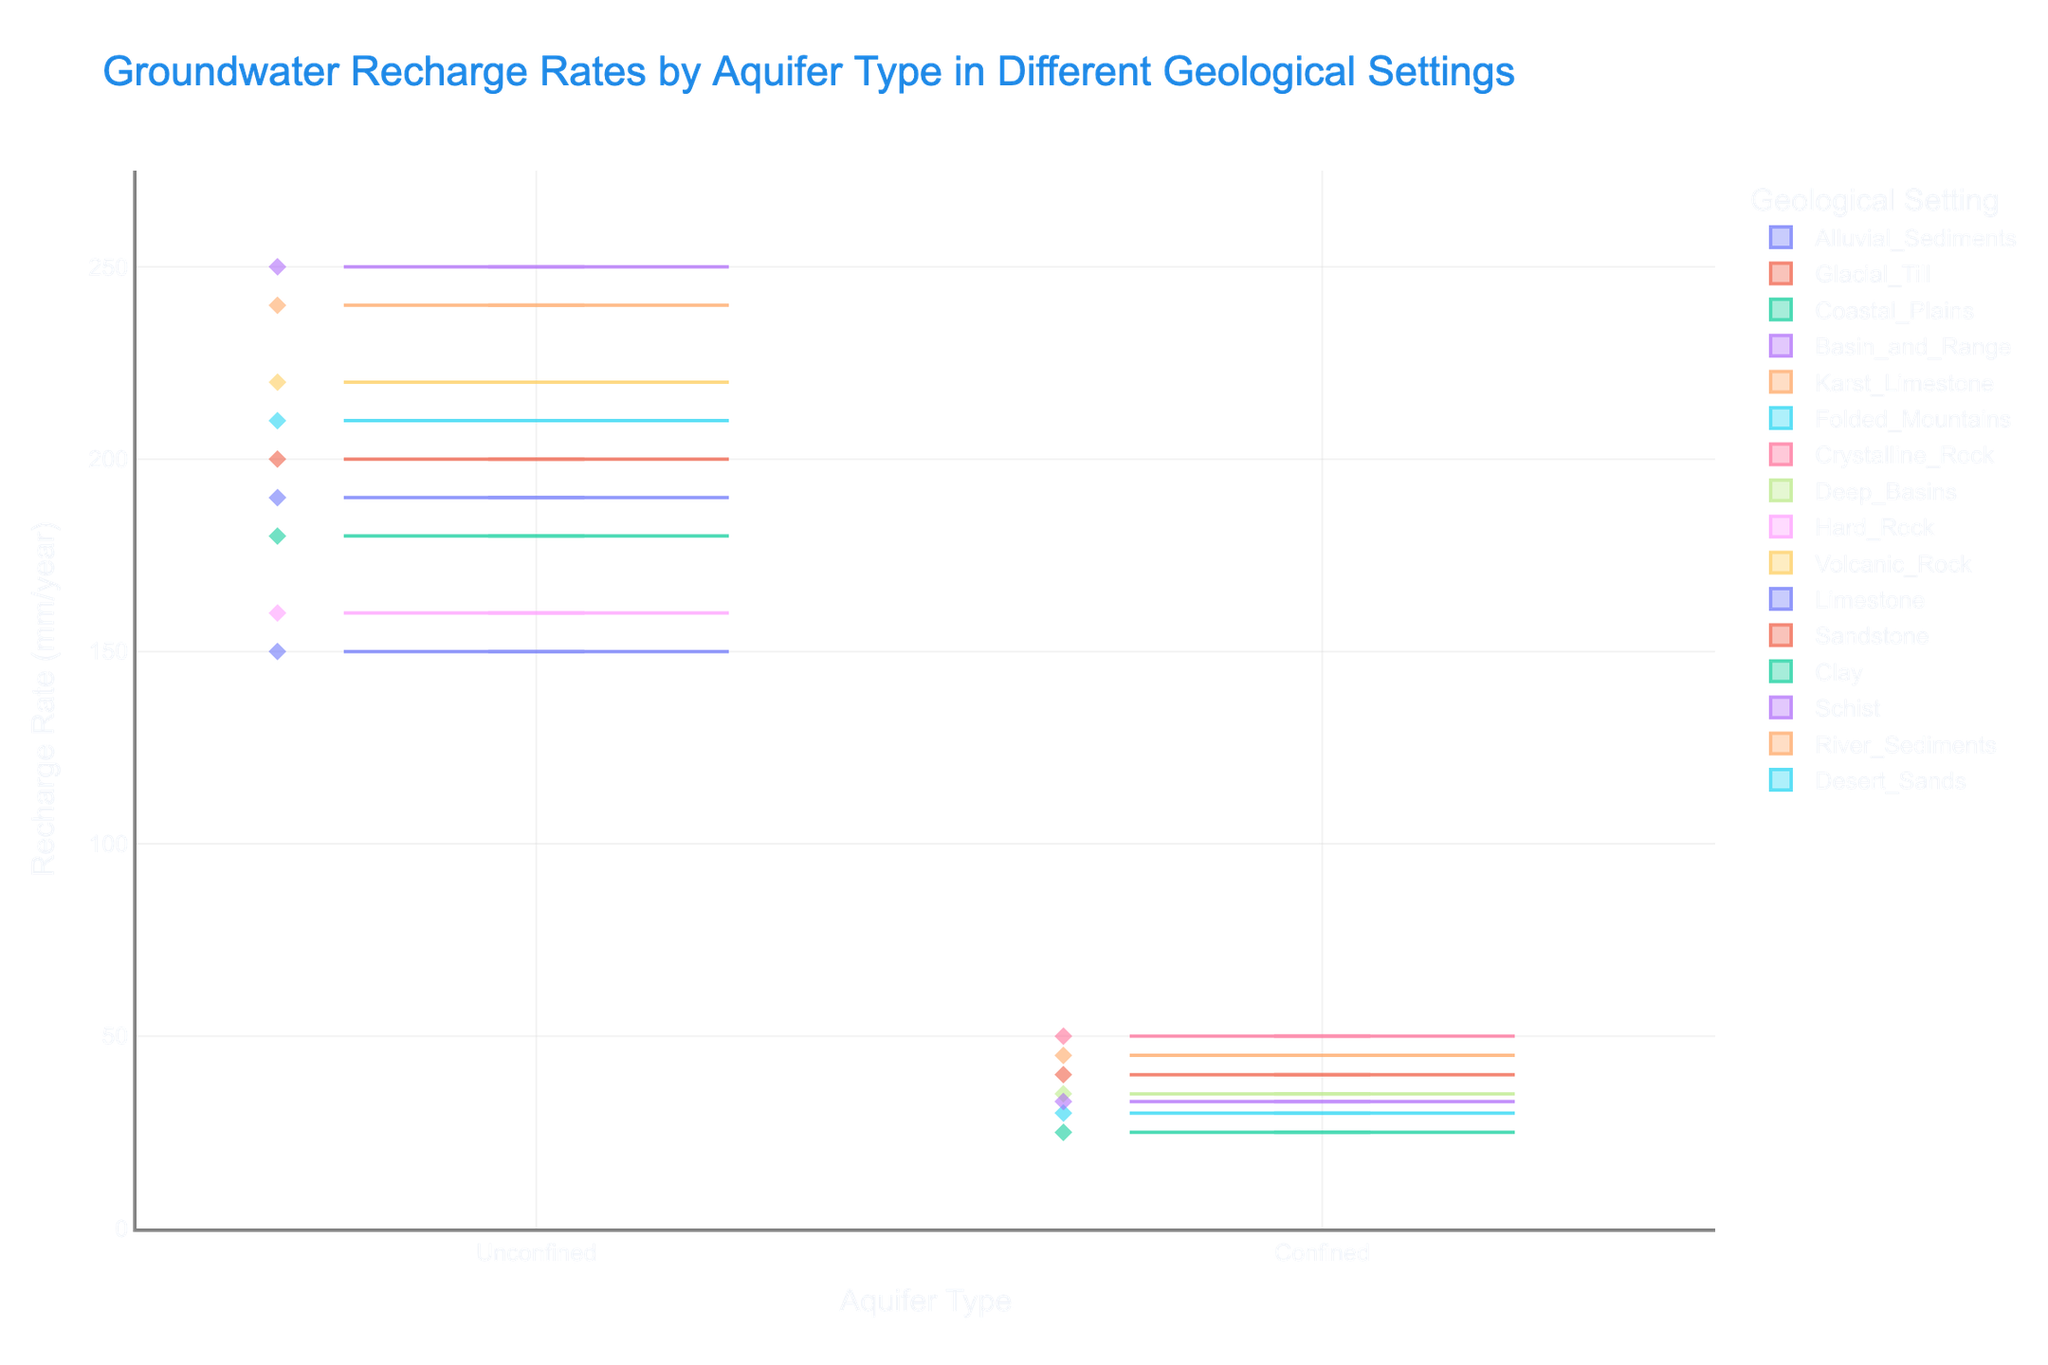What is the title of this violin chart? The title is usually displayed prominently at the top of the chart. In this case, it is clearly stated as "Groundwater Recharge Rates by Aquifer Type in Different Geological Settings".
Answer: Groundwater Recharge Rates by Aquifer Type in Different Geological Settings Which aquifer type has higher recharge rates on average? To determine this, look at the spread and central tendency of the recharge rates for each aquifer type. Unconfined aquifers show data points with higher recharge rates compared to confined aquifers.
Answer: Unconfined What is the range of recharge rates for unconfined aquifers? Examine the violin plot for unconfined aquifers. The range extends from the minimum to maximum recharge rates shown: approximately 150 mm/year to 250 mm/year.
Answer: 150 mm/year to 250 mm/year How many geological settings are represented for unconfined aquifers? Count the distinct colors or categories within the unconfined aquifer section. There are eight geological settings represented.
Answer: Eight Which geological setting has the lowest recharge rate among all the settings? Identify the lowest data point across all geological settings. The lowest recharge rate appears to be from the "Clay" setting, which is around 25 mm/year.
Answer: Clay How does the recharge rate of the Karst Limestone setting compare with those of alluvial sediments? Compare the position of the data points and the spread of the recharge rates of the Karst Limestone setting to those of alluvial sediments. Karst limestone has a lower recharge rate compared to alluvial sediments.
Answer: Karst Limestone is lower What is the median recharge rate for confined aquifers? The median is the middle value in a sorted list of data points. For confined aquifers, the median appears to be around 35-40 mm/year based on the box plot within the violin shape.
Answer: Around 35-40 mm/year What is the difference between the highest recharge rate in confined aquifers and unconfined aquifers? Identify the highest recharge rate in each aquifer type and subtract the confined aquifer's highest rate from the unconfined aquifer's highest rate. Unconfined max is 250 mm/year and confined max is 50 mm/year. 250 - 50 = 200.
Answer: 200 mm/year Which confined geological setting has the highest recharge rate? Look at the confined section and identify the setting with the highest data point. The highest recharge rate in confined aquifers is from the "Crystalline Rock" setting, around 50 mm/year.
Answer: Crystalline Rock Describe the variation in recharge rates for volcanic rock in unconfined aquifers. Examine the shape and spread of the violin for volcanic rock in unconfined aquifers. The data points are relatively high, ranging broadly around 220 mm/year, indicating limited variability and consistency.
Answer: Narrow and consistent around 220 mm/year 